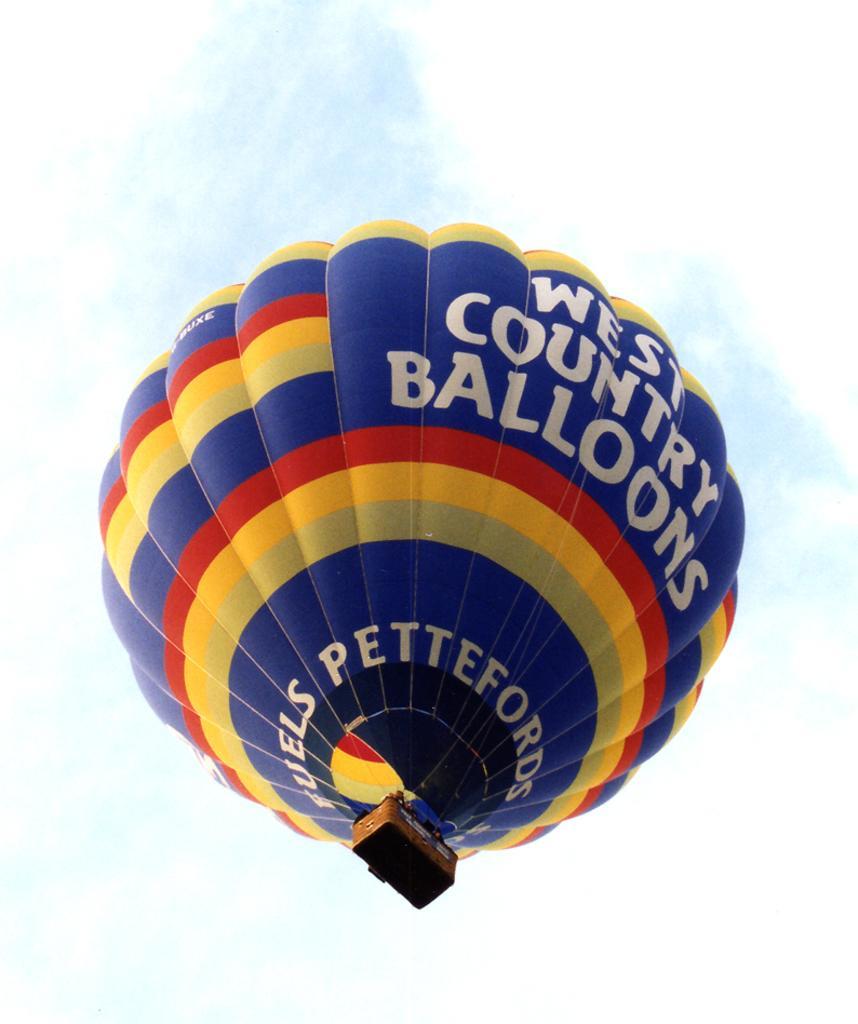Please provide a concise description of this image. In this I can see a big air balloon in blue, red and yellow colors. At the top it is the sky. 